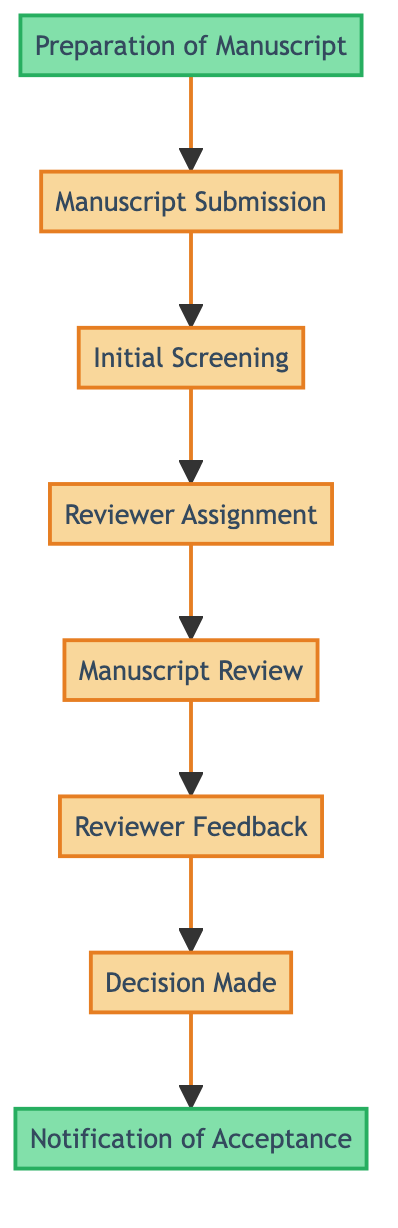What is the first step in the process? The first step in the process, according to the diagram, is "Preparation of Manuscript." It's located at the bottom of the flowchart and is the starting point before any submission occurs.
Answer: Preparation of Manuscript How many steps are in the peer-review submission process? By counting the steps listed in the diagram, there are a total of eight steps that make up the entire peer-review submission process.
Answer: Eight What step follows "Manuscript Submission"? The step that directly follows "Manuscript Submission" is "Initial Screening," as indicated in the flow of the diagram. It is the next process after submission.
Answer: Initial Screening Which step is at the top of the flowchart? The step located at the top of the flowchart is "Notification of Acceptance," indicating that this is the final stage of the process after all prior evaluations and decisions have been made.
Answer: Notification of Acceptance What is needed before the "Decision Made" step? Before reaching the "Decision Made" step, the process requires "Reviewer Feedback." This indicates that the feedback from the reviewers is essential for the editor to make a decision.
Answer: Reviewer Feedback What type of review is conducted in the "Manuscript Review" step? In the "Manuscript Review" step, the type of review conducted is an evaluation of the manuscript's quality, relevance, and accuracy by assigned reviewers.
Answer: Evaluation Which step includes subject-matter experts? The "Reviewer Assignment" step includes the involvement of subject-matter experts, as the journal editor assigns the manuscript to them for review.
Answer: Reviewer Assignment What is the relationship between "Initial Screening" and "Manuscript Submission"? The relationship is sequential; "Initial Screening" directly follows "Manuscript Submission," meaning that initial checks are conducted immediately after the manuscript is submitted.
Answer: Sequential 